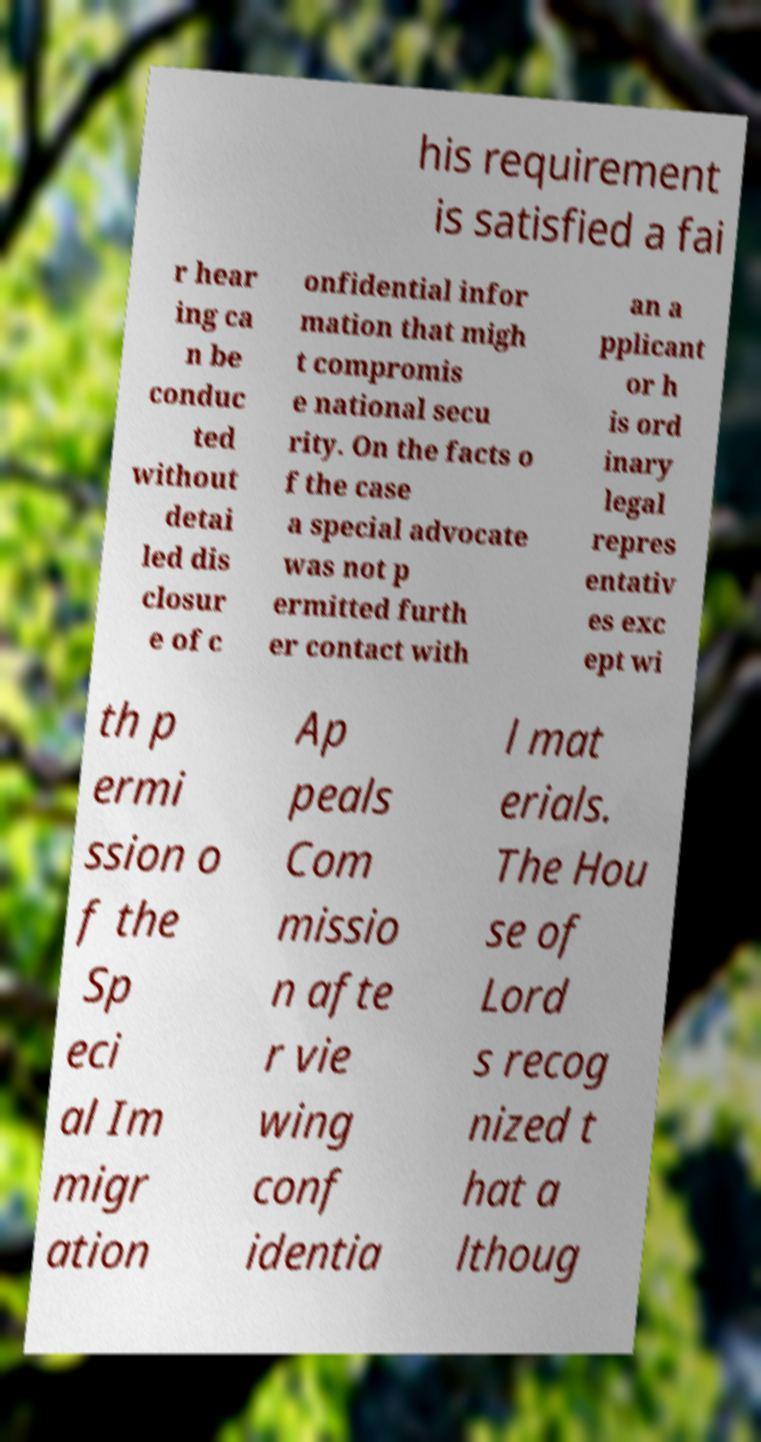There's text embedded in this image that I need extracted. Can you transcribe it verbatim? his requirement is satisfied a fai r hear ing ca n be conduc ted without detai led dis closur e of c onfidential infor mation that migh t compromis e national secu rity. On the facts o f the case a special advocate was not p ermitted furth er contact with an a pplicant or h is ord inary legal repres entativ es exc ept wi th p ermi ssion o f the Sp eci al Im migr ation Ap peals Com missio n afte r vie wing conf identia l mat erials. The Hou se of Lord s recog nized t hat a lthoug 